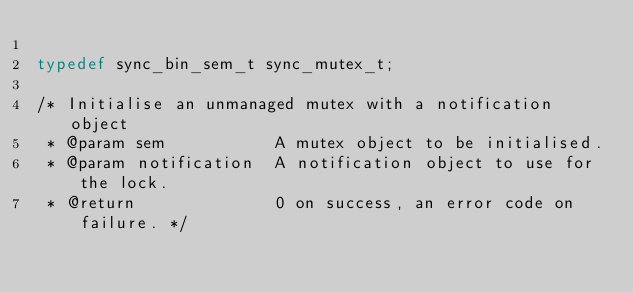Convert code to text. <code><loc_0><loc_0><loc_500><loc_500><_C_>
typedef sync_bin_sem_t sync_mutex_t;

/* Initialise an unmanaged mutex with a notification object
 * @param sem           A mutex object to be initialised.
 * @param notification  A notification object to use for the lock.
 * @return              0 on success, an error code on failure. */</code> 